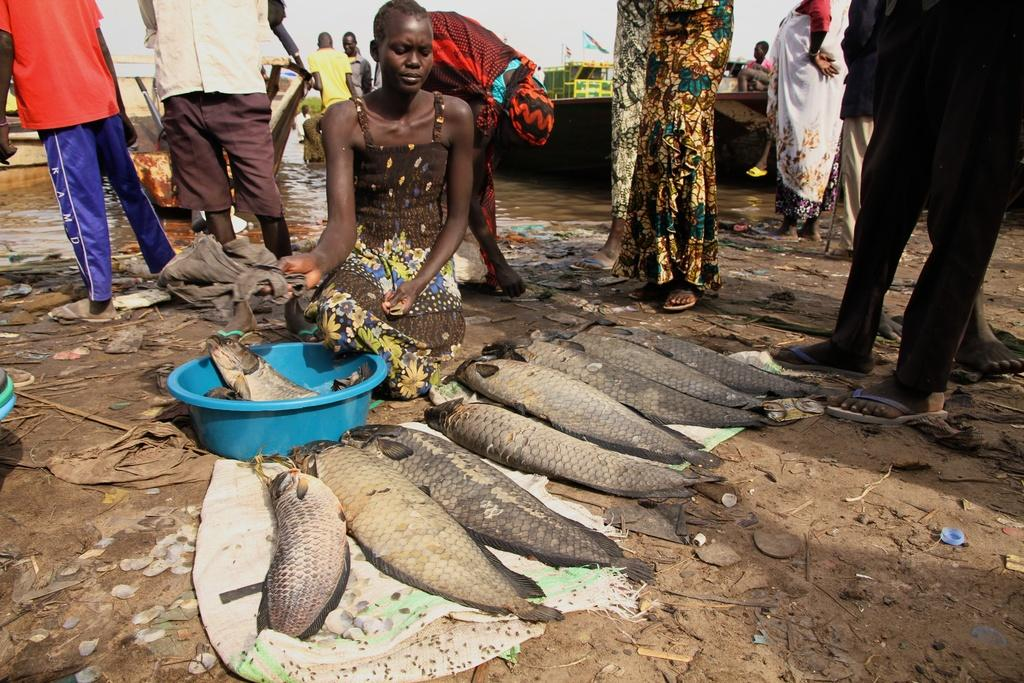What is on the ground in the image? There are fish on the ground in the image. What else can be seen in the image besides the fish? There are people standing in the image. What can be seen in the distance in the image? Ships are visible in the background of the image. What is the condition of the sky in the image? The sky is clear in the image. Can you hear the queen speaking in the image? There is no audio or indication of a queen present in the image, so it is not possible to hear her speaking. 